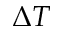Convert formula to latex. <formula><loc_0><loc_0><loc_500><loc_500>\Delta T</formula> 